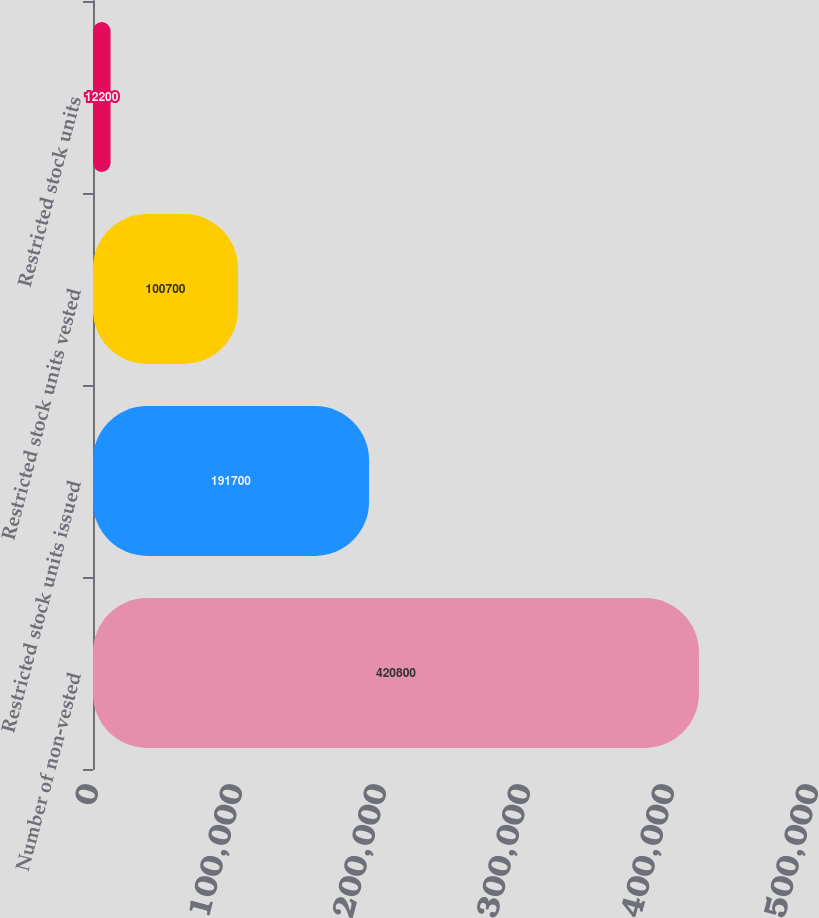<chart> <loc_0><loc_0><loc_500><loc_500><bar_chart><fcel>Number of non-vested<fcel>Restricted stock units issued<fcel>Restricted stock units vested<fcel>Restricted stock units<nl><fcel>420800<fcel>191700<fcel>100700<fcel>12200<nl></chart> 